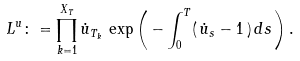Convert formula to latex. <formula><loc_0><loc_0><loc_500><loc_500>L ^ { u } \colon = \prod _ { k = 1 } ^ { X _ { T } } \dot { u } _ { T _ { k } } \, \exp \left ( \, - \int _ { 0 } ^ { T } ( \, \dot { u } _ { s } - 1 \, ) \, d s \, \right ) .</formula> 